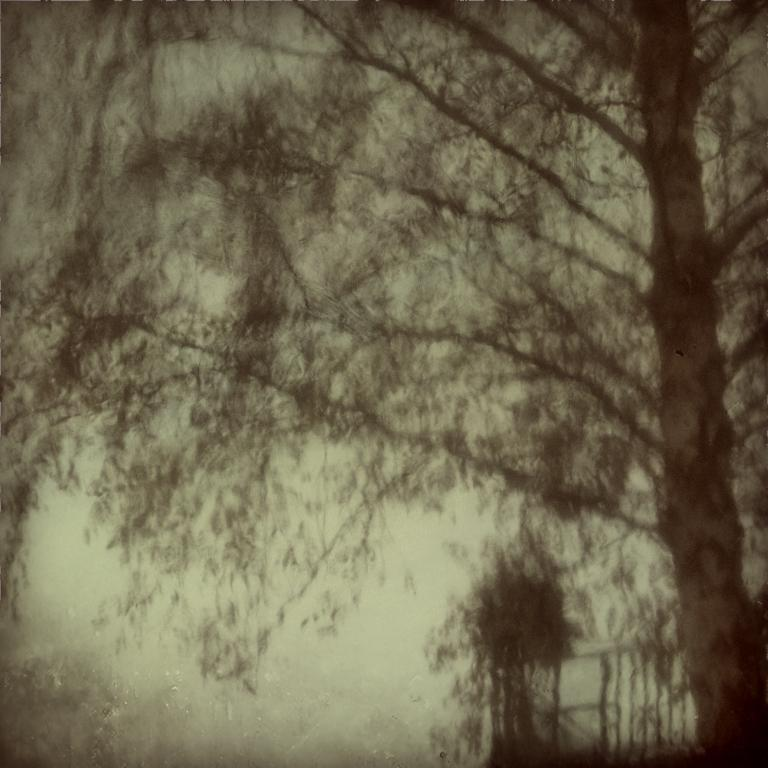What type of vegetation is on the right side of the image? There is a tree on the right side of the image. How would you describe the overall lighting in the image? The background of the image is dark. Can you describe the quality of the background in the image? The background of the image is blurry. What type of punishment is being handed out in the image? There is no indication of punishment in the image; it features a tree and a blurry background. What type of humor can be seen in the image? There is no humor present in the image; it features a tree and a blurry background. 